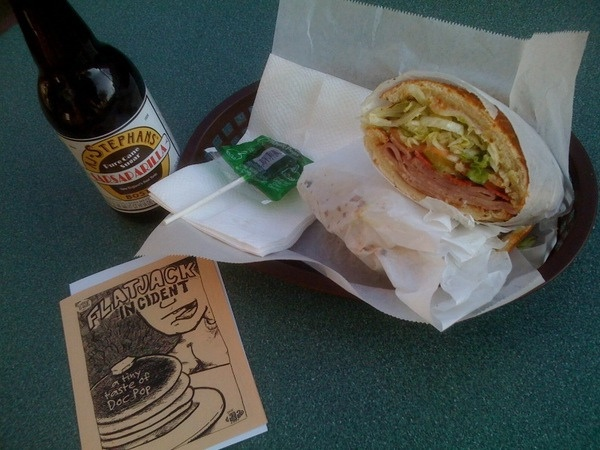Describe the objects in this image and their specific colors. I can see book in black and gray tones, bottle in black, gray, darkgray, and maroon tones, and sandwich in black, olive, and maroon tones in this image. 